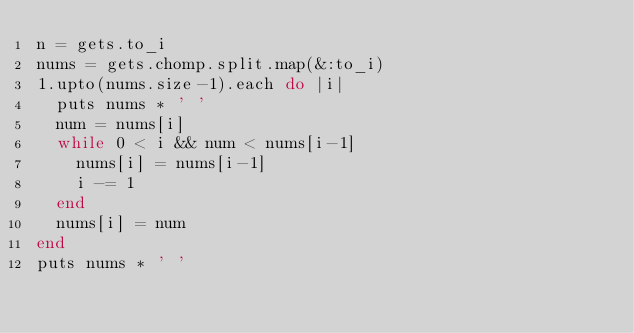<code> <loc_0><loc_0><loc_500><loc_500><_Ruby_>n = gets.to_i
nums = gets.chomp.split.map(&:to_i)
1.upto(nums.size-1).each do |i|
  puts nums * ' '
  num = nums[i]
  while 0 < i && num < nums[i-1]
    nums[i] = nums[i-1]
    i -= 1
  end
  nums[i] = num
end
puts nums * ' '</code> 